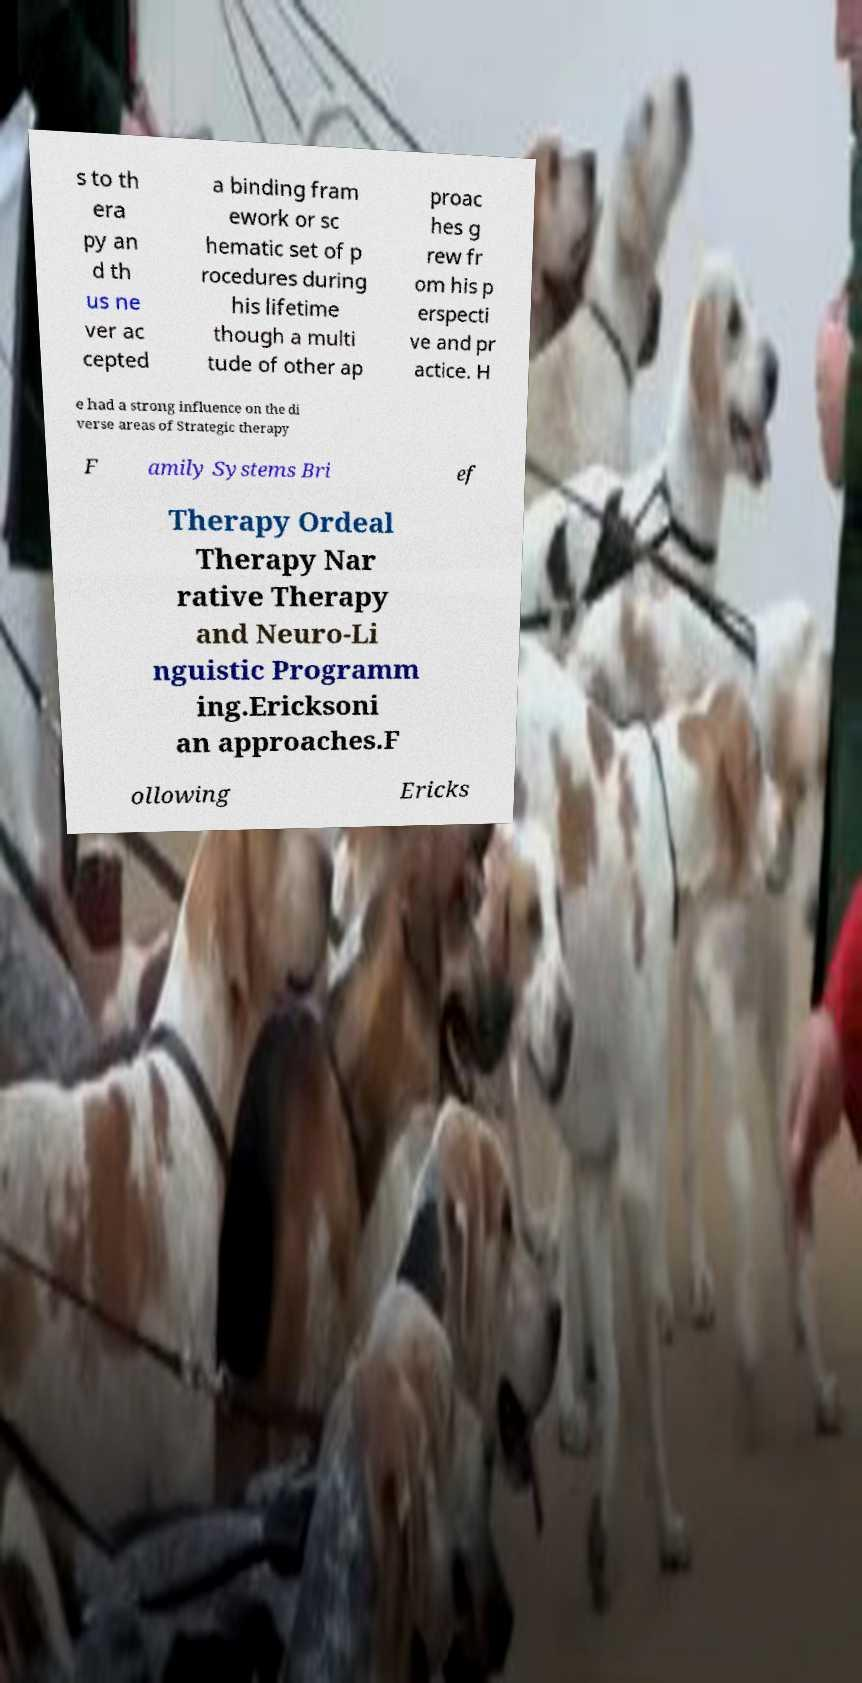Can you accurately transcribe the text from the provided image for me? s to th era py an d th us ne ver ac cepted a binding fram ework or sc hematic set of p rocedures during his lifetime though a multi tude of other ap proac hes g rew fr om his p erspecti ve and pr actice. H e had a strong influence on the di verse areas of Strategic therapy F amily Systems Bri ef Therapy Ordeal Therapy Nar rative Therapy and Neuro-Li nguistic Programm ing.Ericksoni an approaches.F ollowing Ericks 